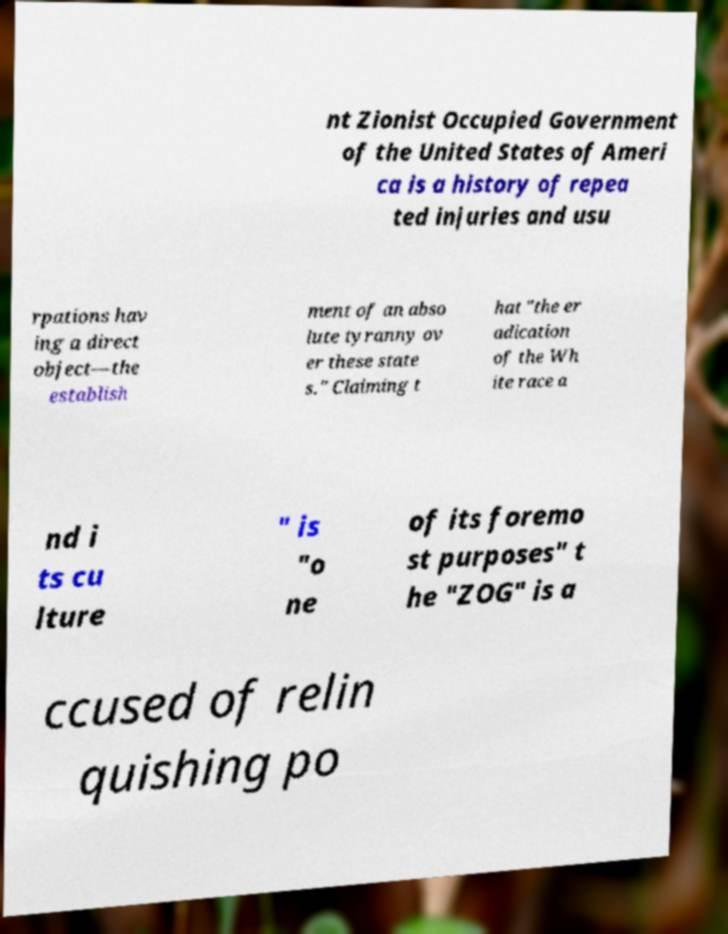Can you accurately transcribe the text from the provided image for me? nt Zionist Occupied Government of the United States of Ameri ca is a history of repea ted injuries and usu rpations hav ing a direct object—the establish ment of an abso lute tyranny ov er these state s." Claiming t hat "the er adication of the Wh ite race a nd i ts cu lture " is "o ne of its foremo st purposes" t he "ZOG" is a ccused of relin quishing po 